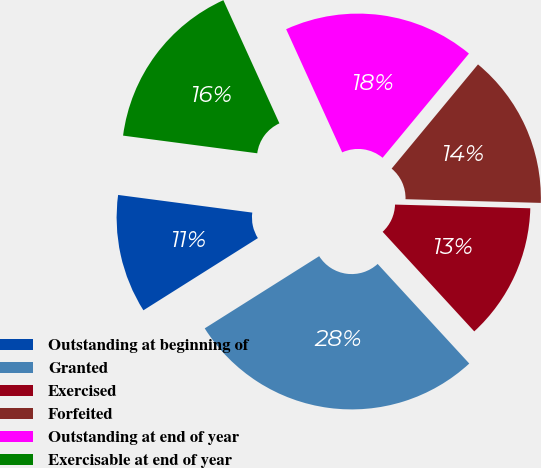<chart> <loc_0><loc_0><loc_500><loc_500><pie_chart><fcel>Outstanding at beginning of<fcel>Granted<fcel>Exercised<fcel>Forfeited<fcel>Outstanding at end of year<fcel>Exercisable at end of year<nl><fcel>11.04%<fcel>27.88%<fcel>12.73%<fcel>14.42%<fcel>17.81%<fcel>16.12%<nl></chart> 